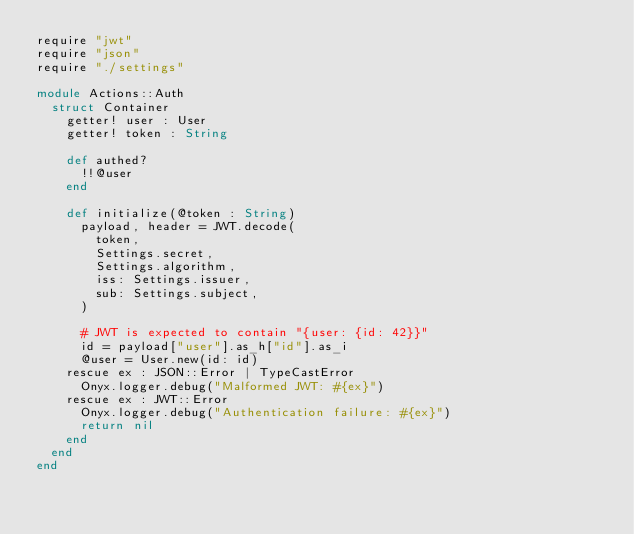Convert code to text. <code><loc_0><loc_0><loc_500><loc_500><_Crystal_>require "jwt"
require "json"
require "./settings"

module Actions::Auth
  struct Container
    getter! user : User
    getter! token : String

    def authed?
      !!@user
    end

    def initialize(@token : String)
      payload, header = JWT.decode(
        token,
        Settings.secret,
        Settings.algorithm,
        iss: Settings.issuer,
        sub: Settings.subject,
      )

      # JWT is expected to contain "{user: {id: 42}}"
      id = payload["user"].as_h["id"].as_i
      @user = User.new(id: id)
    rescue ex : JSON::Error | TypeCastError
      Onyx.logger.debug("Malformed JWT: #{ex}")
    rescue ex : JWT::Error
      Onyx.logger.debug("Authentication failure: #{ex}")
      return nil
    end
  end
end
</code> 